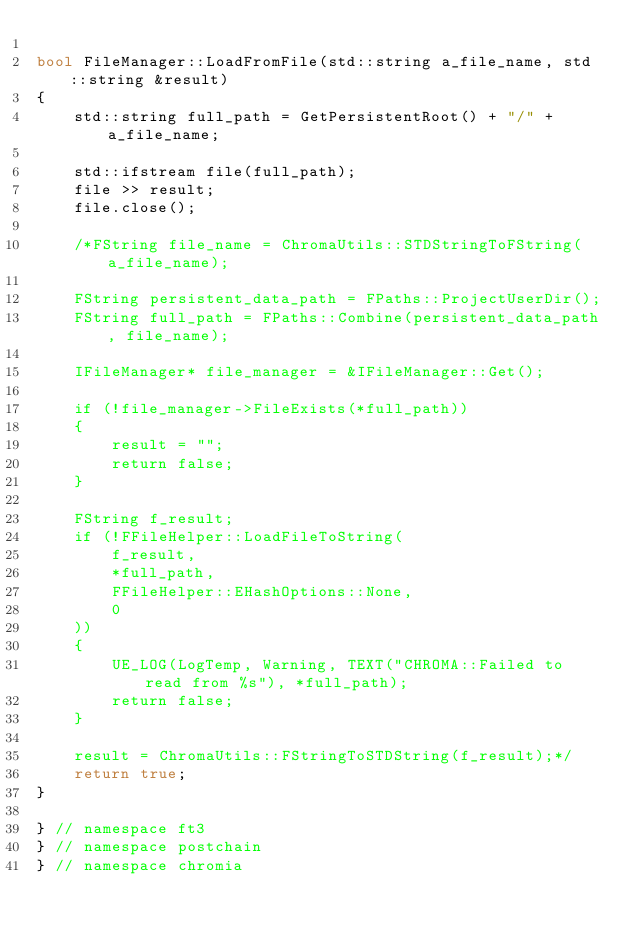<code> <loc_0><loc_0><loc_500><loc_500><_C++_>
bool FileManager::LoadFromFile(std::string a_file_name, std::string &result)
{
	std::string full_path = GetPersistentRoot() + "/" + a_file_name;

	std::ifstream file(full_path);
	file >> result;
	file.close();

	/*FString file_name = ChromaUtils::STDStringToFString(a_file_name);

	FString persistent_data_path = FPaths::ProjectUserDir();
	FString full_path = FPaths::Combine(persistent_data_path, file_name);

	IFileManager* file_manager = &IFileManager::Get();

	if (!file_manager->FileExists(*full_path))
	{
		result = "";
		return false;
	}

	FString f_result;
	if (!FFileHelper::LoadFileToString(
		f_result,
		*full_path,
		FFileHelper::EHashOptions::None,
		0
	))
	{
		UE_LOG(LogTemp, Warning, TEXT("CHROMA::Failed to read from %s"), *full_path);
		return false;
	}

	result = ChromaUtils::FStringToSTDString(f_result);*/
	return true;
}

} // namespace ft3
} // namespace postchain
} // namespace chromia</code> 